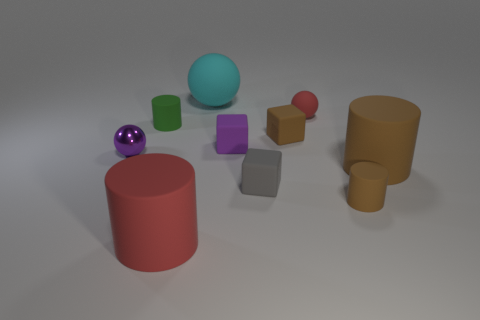Is the purple shiny object the same size as the red sphere?
Give a very brief answer. Yes. Do the tiny sphere that is right of the small green rubber object and the tiny purple sphere have the same material?
Offer a terse response. No. Are there fewer red rubber things that are in front of the red sphere than large red rubber cubes?
Your answer should be very brief. No. There is a gray matte object behind the big red thing; what shape is it?
Offer a very short reply. Cube. What shape is the red rubber thing that is the same size as the gray cube?
Your answer should be very brief. Sphere. Is there a brown object that has the same shape as the gray rubber object?
Give a very brief answer. Yes. There is a red object left of the gray cube; is its shape the same as the tiny rubber object that is in front of the gray object?
Offer a terse response. Yes. What is the material of the ball that is the same size as the red cylinder?
Your answer should be compact. Rubber. How many other things are the same material as the small brown cylinder?
Provide a succinct answer. 8. The purple object that is left of the big rubber thing that is in front of the small gray cube is what shape?
Make the answer very short. Sphere. 